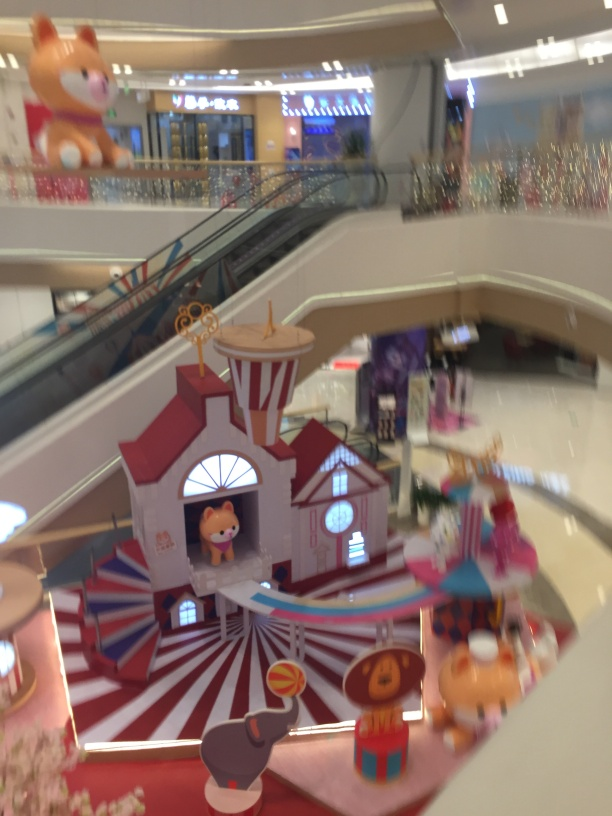Can you describe the atmosphere or purpose of the location shown in the image? The image conveys a playful and whimsical atmosphere. It seems to be an indoor display designed for children, possibly within a shopping mall, to create an engaging environment. The bright colors, cartoon-like figures, and the fairground layout suggest it's meant to entertain and perhaps to host children's activities or events. 